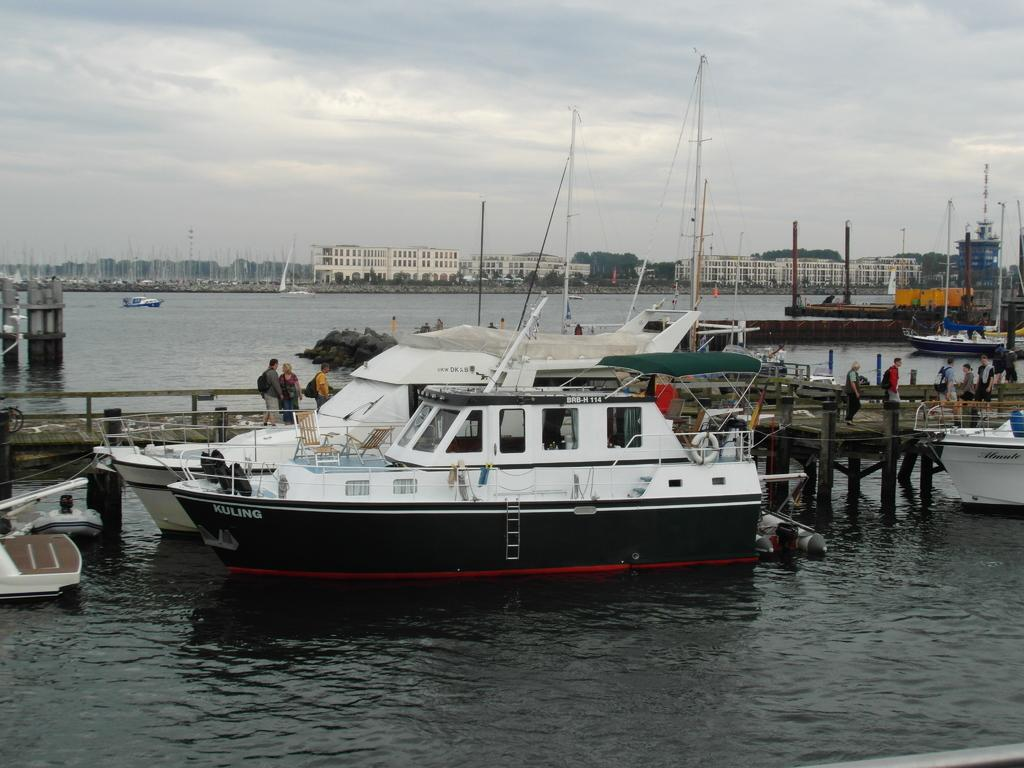What is floating on the water in the image? There are boats floating on the water in the image. What can be seen in the background of the image? There is a river, buildings, trees, and clouds visible in the background of the image. What type of shoes can be seen on the boats in the image? There are no shoes visible on the boats in the image. What kind of button is being used to control the boats in the image? There is no button present in the image, and the boats are floating on the water naturally. Can you see a bear swimming in the river in the image? There is no bear visible in the image; only boats, water, and the background elements are present. 